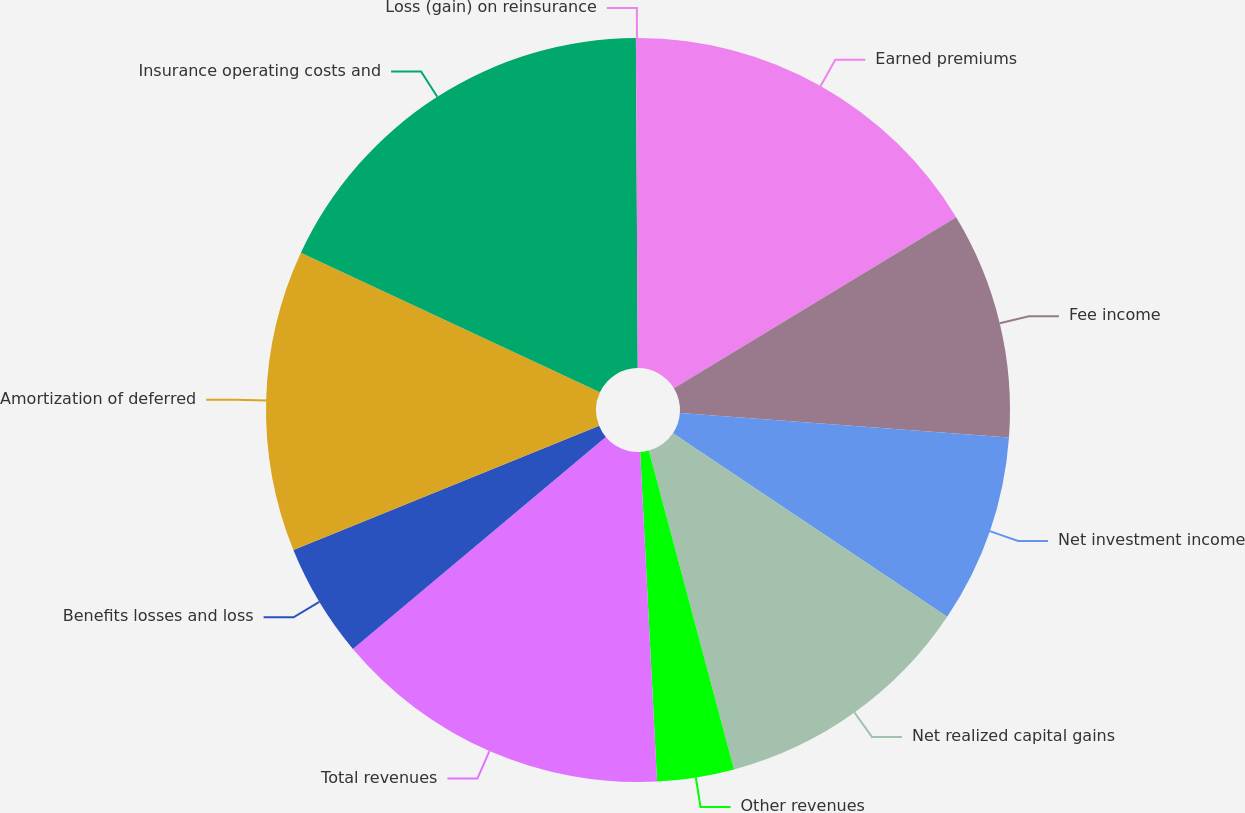<chart> <loc_0><loc_0><loc_500><loc_500><pie_chart><fcel>Earned premiums<fcel>Fee income<fcel>Net investment income<fcel>Net realized capital gains<fcel>Other revenues<fcel>Total revenues<fcel>Benefits losses and loss<fcel>Amortization of deferred<fcel>Insurance operating costs and<fcel>Loss (gain) on reinsurance<nl><fcel>16.33%<fcel>9.84%<fcel>8.21%<fcel>11.46%<fcel>3.34%<fcel>14.71%<fcel>4.96%<fcel>13.09%<fcel>17.96%<fcel>0.09%<nl></chart> 